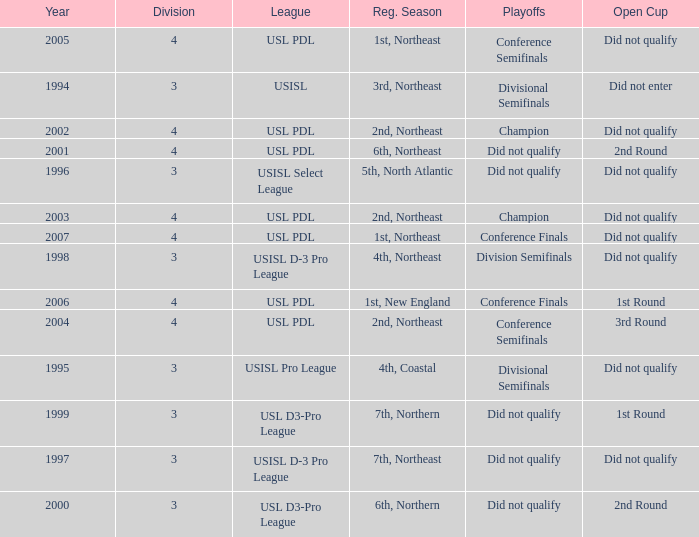Name the total number of years for usisl pro league 1.0. 